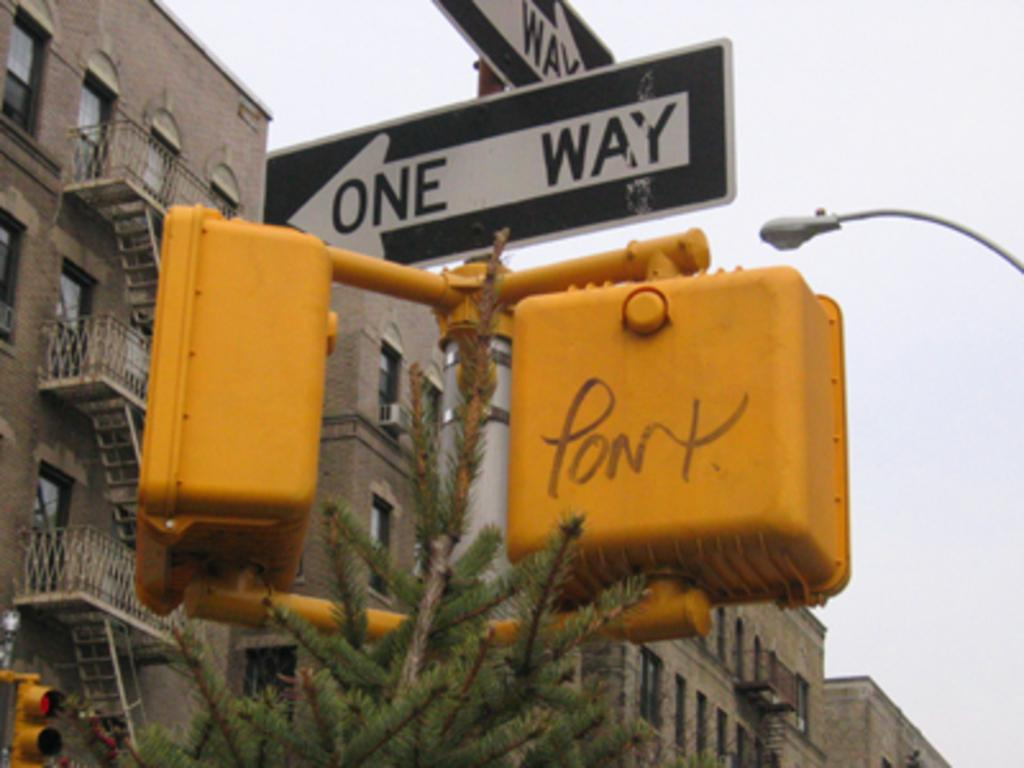What type of signals are present in the image? There are traffic signals in the image. What other objects can be seen in the image? There are boards, lights, poles, buildings, steps, and railings in the image. How are the lights positioned in the image? The lights are attached to poles in the image. What is visible in the background of the image? The sky is visible in the background of the image. Can you tell me how many quills are used to write on the boards in the image? There are no quills present in the image; the boards are likely used for displaying information or advertisements. What type of afterthought is depicted in the image? There is no afterthought depicted in the image; the focus is on the traffic signals, boards, lights, poles, buildings, steps, railings, and sky. 